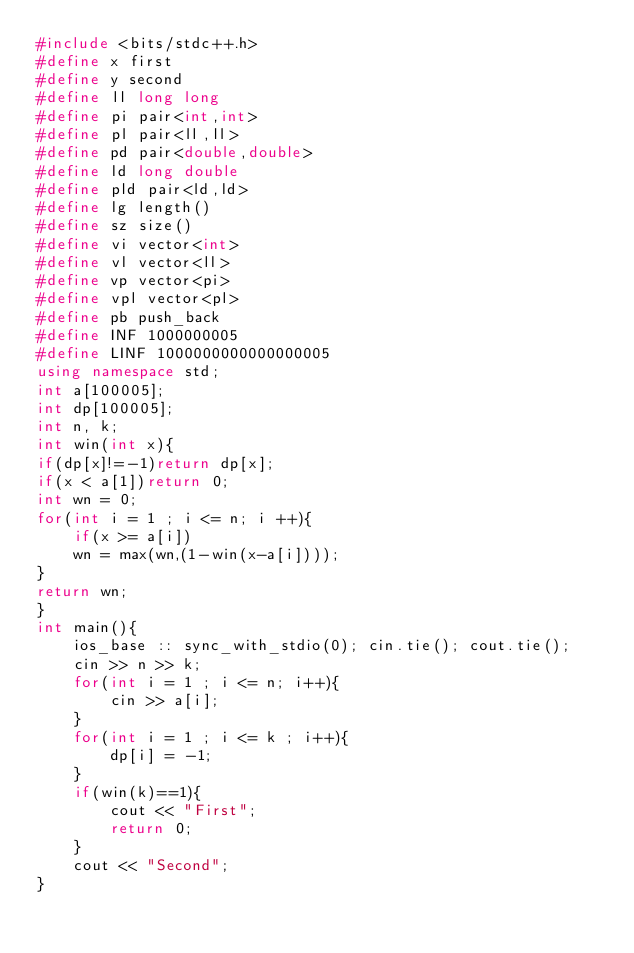<code> <loc_0><loc_0><loc_500><loc_500><_C++_>#include <bits/stdc++.h>
#define x first
#define y second
#define ll long long
#define pi pair<int,int>
#define pl pair<ll,ll>
#define pd pair<double,double>
#define ld long double
#define pld pair<ld,ld>
#define lg length()
#define sz size()
#define vi vector<int>
#define vl vector<ll>
#define vp vector<pi>
#define vpl vector<pl>
#define pb push_back
#define INF 1000000005
#define LINF 1000000000000000005
using namespace std;
int a[100005];
int dp[100005];
int n, k;
int win(int x){
if(dp[x]!=-1)return dp[x];
if(x < a[1])return 0;
int wn = 0;
for(int i = 1 ; i <= n; i ++){
    if(x >= a[i])
    wn = max(wn,(1-win(x-a[i])));
}
return wn;
}
int main(){
    ios_base :: sync_with_stdio(0); cin.tie(); cout.tie();
    cin >> n >> k;
    for(int i = 1 ; i <= n; i++){
        cin >> a[i];
    }
    for(int i = 1 ; i <= k ; i++){
        dp[i] = -1;
    }
    if(win(k)==1){
        cout << "First";
        return 0;
    }
    cout << "Second";
}

</code> 